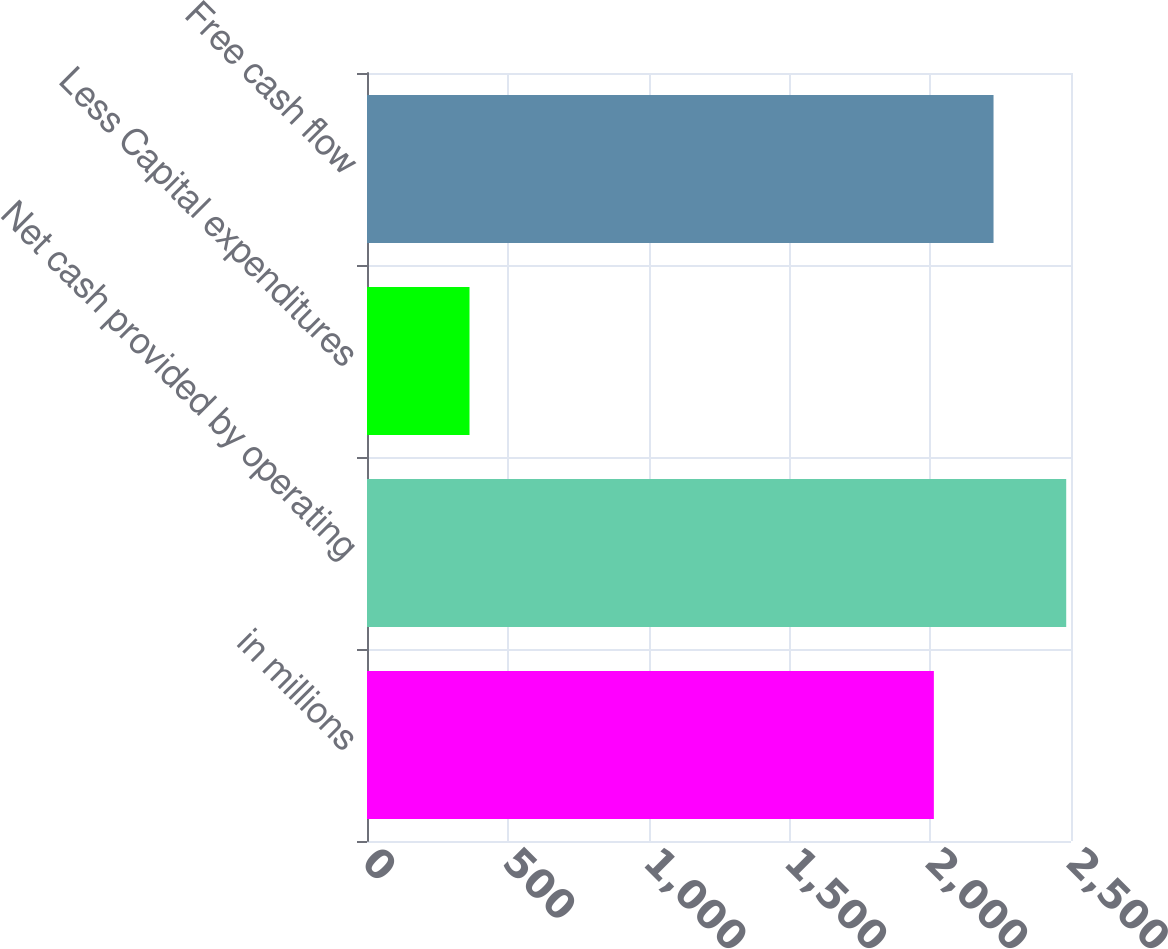Convert chart to OTSL. <chart><loc_0><loc_0><loc_500><loc_500><bar_chart><fcel>in millions<fcel>Net cash provided by operating<fcel>Less Capital expenditures<fcel>Free cash flow<nl><fcel>2013<fcel>2483<fcel>364<fcel>2224.9<nl></chart> 